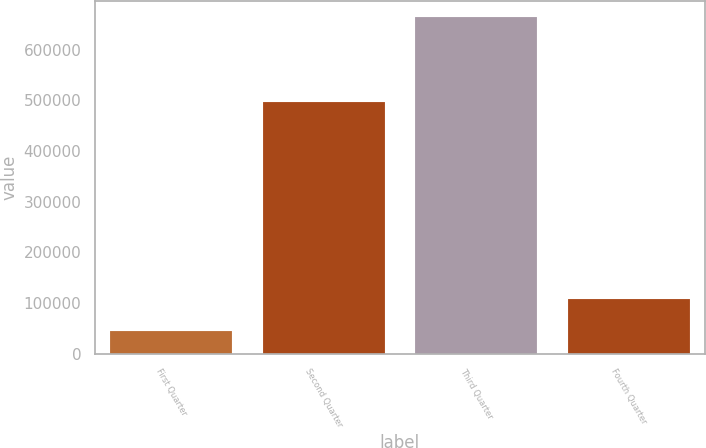<chart> <loc_0><loc_0><loc_500><loc_500><bar_chart><fcel>First Quarter<fcel>Second Quarter<fcel>Third Quarter<fcel>Fourth Quarter<nl><fcel>45675<fcel>496154<fcel>663689<fcel>107476<nl></chart> 